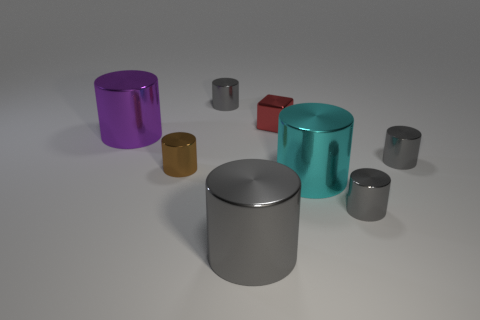Subtract all gray cylinders. How many were subtracted if there are1gray cylinders left? 3 Subtract all green balls. How many gray cylinders are left? 4 Subtract all purple cylinders. How many cylinders are left? 6 Subtract all brown metal cylinders. How many cylinders are left? 6 Subtract all purple cylinders. Subtract all gray blocks. How many cylinders are left? 6 Add 1 metallic cylinders. How many objects exist? 9 Subtract all cubes. How many objects are left? 7 Add 5 purple metal things. How many purple metal things are left? 6 Add 4 gray cylinders. How many gray cylinders exist? 8 Subtract 0 yellow balls. How many objects are left? 8 